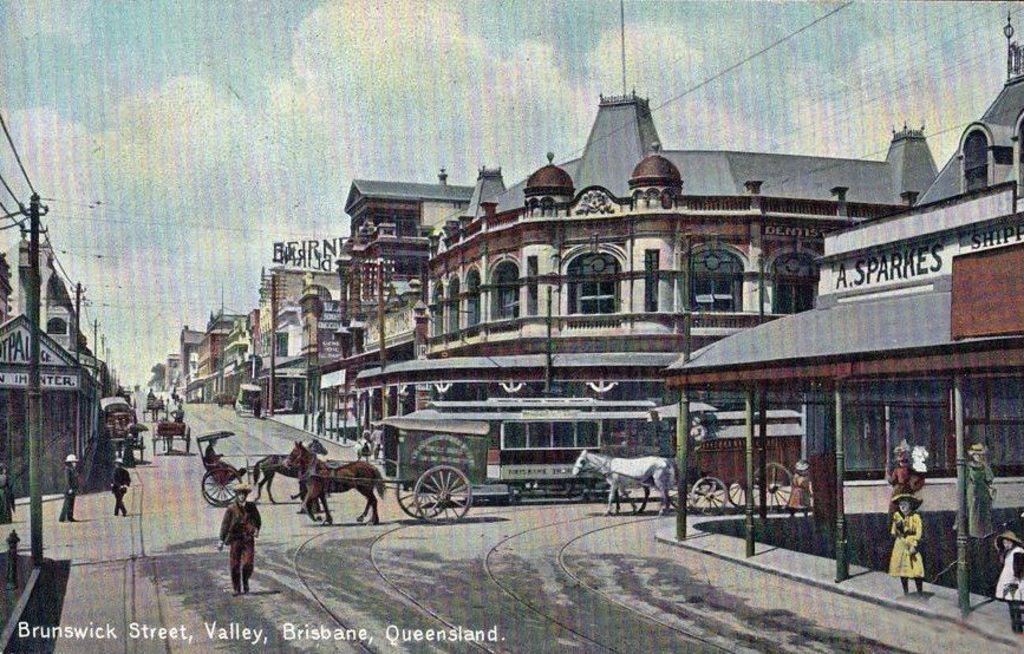Describe this image in one or two sentences. In this picture I can see a poster, there are vehicles on the road, there are horses, there are group of people, there are poles, cables, there are buildings, and in the background there is the sky on the poster, and there is a watermark on the image. 